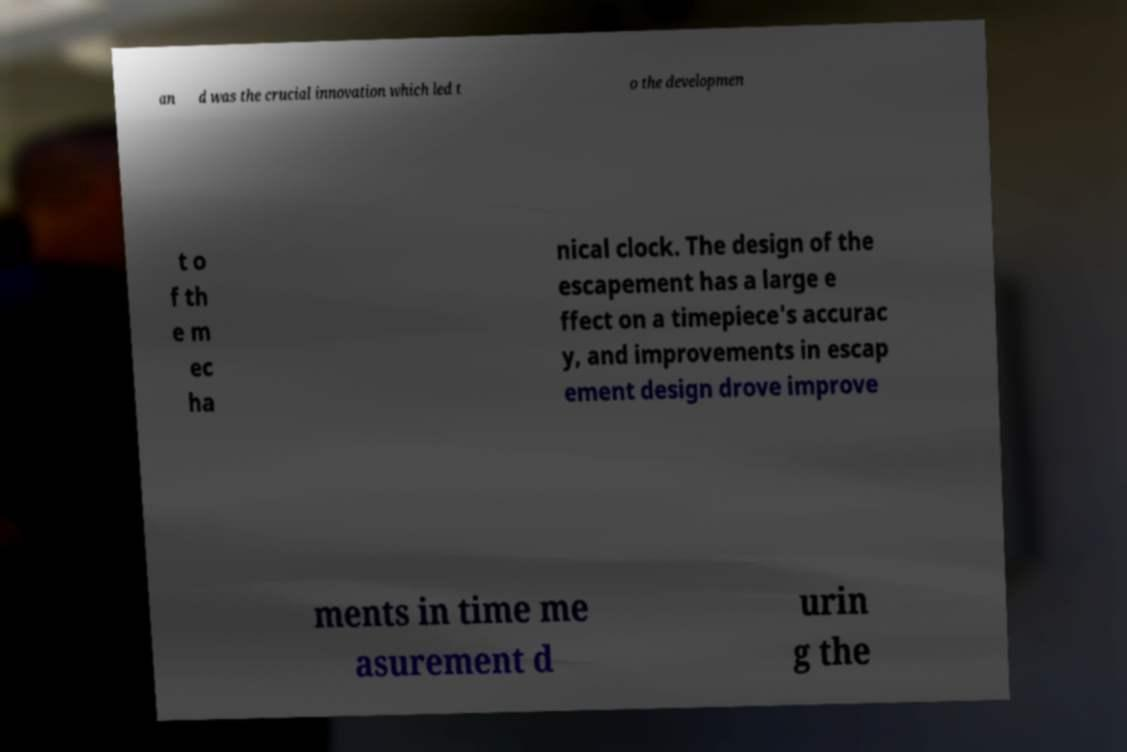What messages or text are displayed in this image? I need them in a readable, typed format. an d was the crucial innovation which led t o the developmen t o f th e m ec ha nical clock. The design of the escapement has a large e ffect on a timepiece's accurac y, and improvements in escap ement design drove improve ments in time me asurement d urin g the 